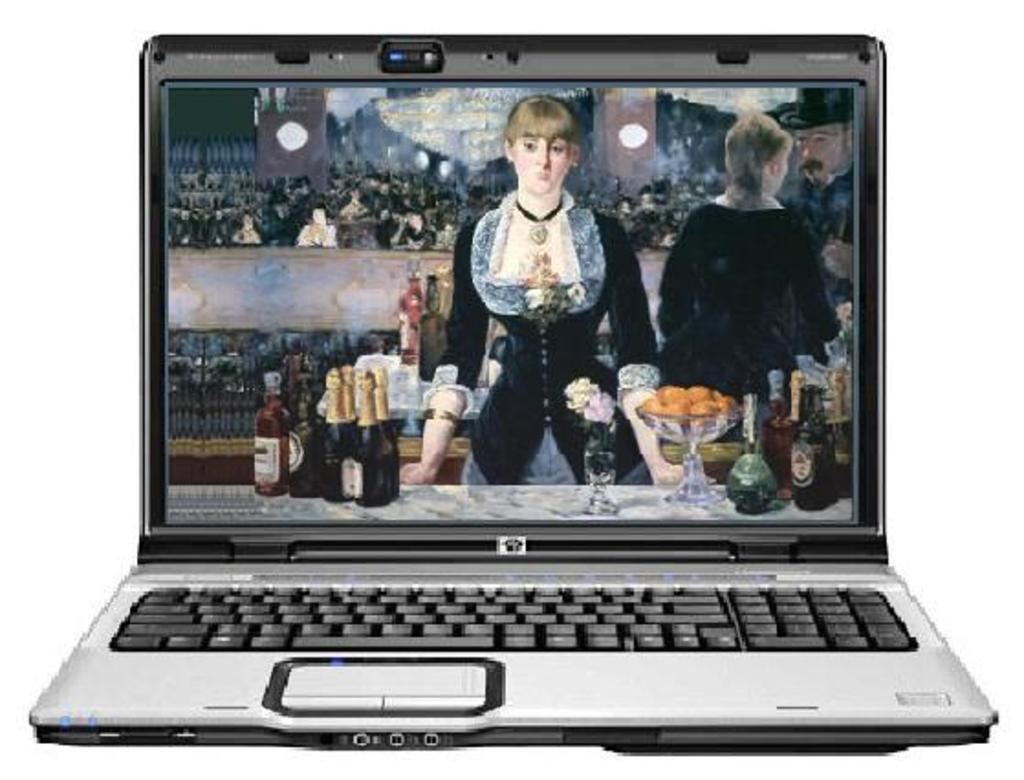What electronic device is visible in the image? There is a laptop in the image. Where is the sofa located in the image? There is no sofa present in the image; it only features a laptop. What type of insect can be seen crawling on the laptop in the image? There are no insects, such as beetles, present on the laptop in the image. 